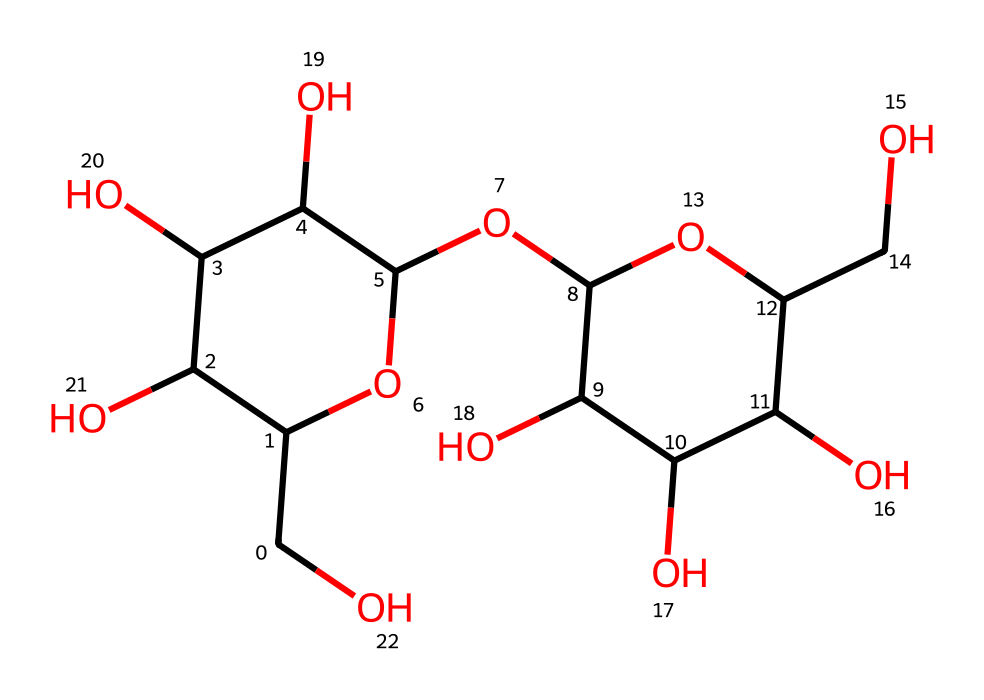How many carbon atoms are present in the structure? By examining the SMILES representation, we can count the number of 'C' letters that represent carbon atoms. This molecule has a total of twelve 'C' in its structure.
Answer: twelve What type of carbohydrate is lactose classified as? Lactose is a disaccharide since it is composed of two monosaccharides (glucose and galactose) linked together.
Answer: disaccharide Which functional groups are present in this lactose structure? The structure has multiple hydroxyl (-OH) groups which indicate the presence of alcohol functional groups; this is typical for carbohydrates.
Answer: hydroxyl groups What is the molecular formula for lactose based on this structure? By parsing the SMILES representation, we can derive its molecular formula as C12H22O11, corresponding to the quantities of carbon, hydrogen, and oxygen atoms present in the structure.
Answer: C12H22O11 How does lactose contribute to bone health in pilots? Lactose provides energy and helps in the absorption of calcium, which is crucial for maintaining bone density, especially important for pilots who may have varying physical stresses.
Answer: calcium absorption What is the relationship between lactose and dairy products? Lactose is naturally found in milk and milk-derived products, which is why dairy products contain this carbohydrate.
Answer: naturally occurring Why is the arrangement of atoms in lactose significant for its function? The specific arrangement allows lactose to be broken down by lactase enzymes in the body, resulting in glucose and galactose that can be utilized for energy, affecting metabolism and energy levels.
Answer: metabolic energy 